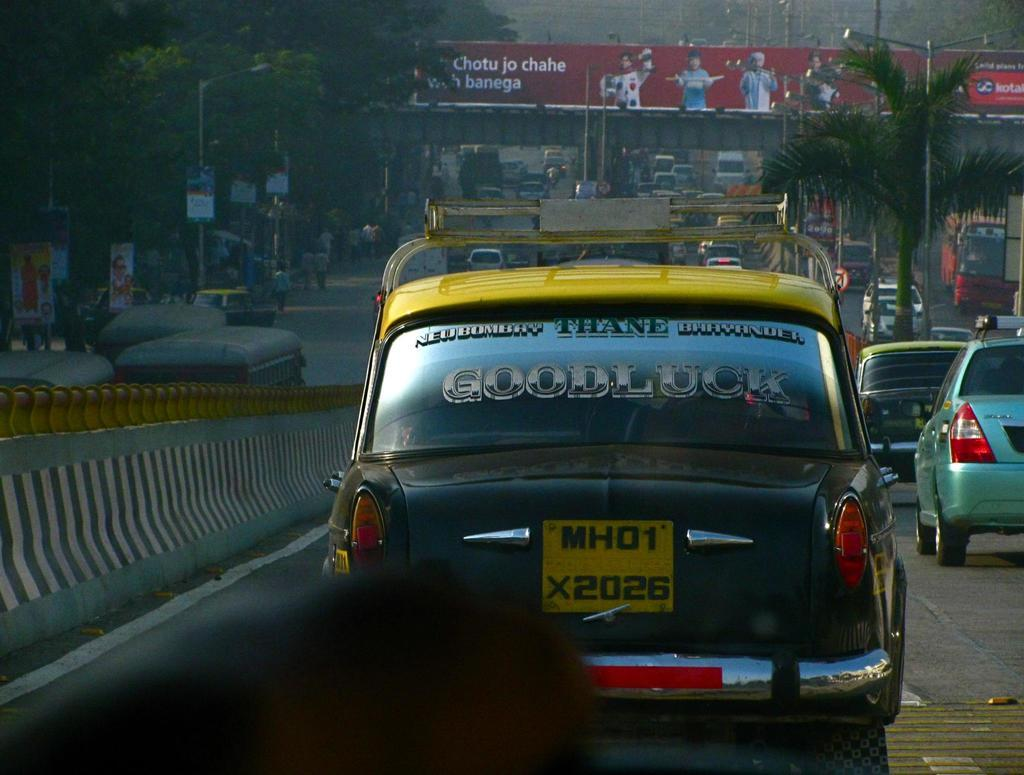<image>
Give a short and clear explanation of the subsequent image. Taxicab that says MH01 X2026 and has a sign that says Goodluck on it. 